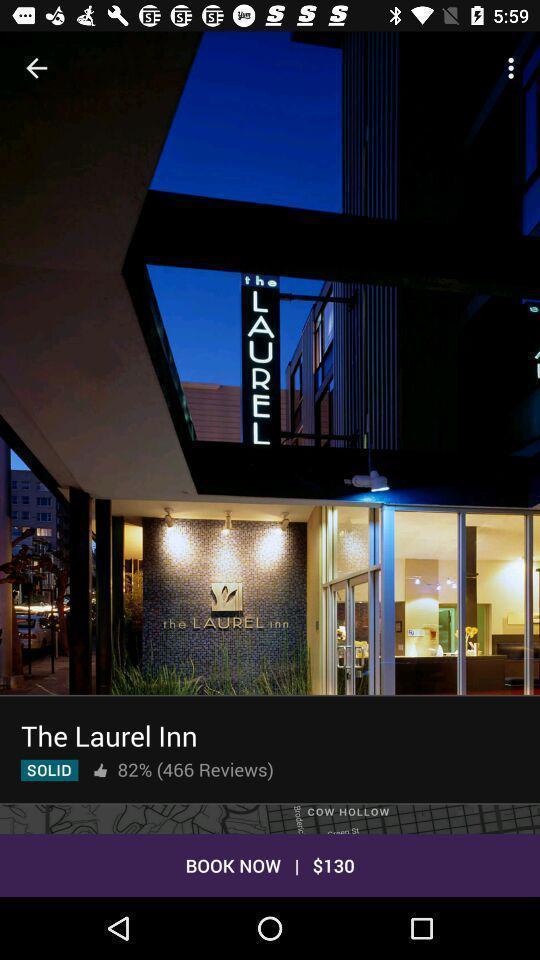Describe this image in words. Screen page displaying reviews of hotel in booking application. 